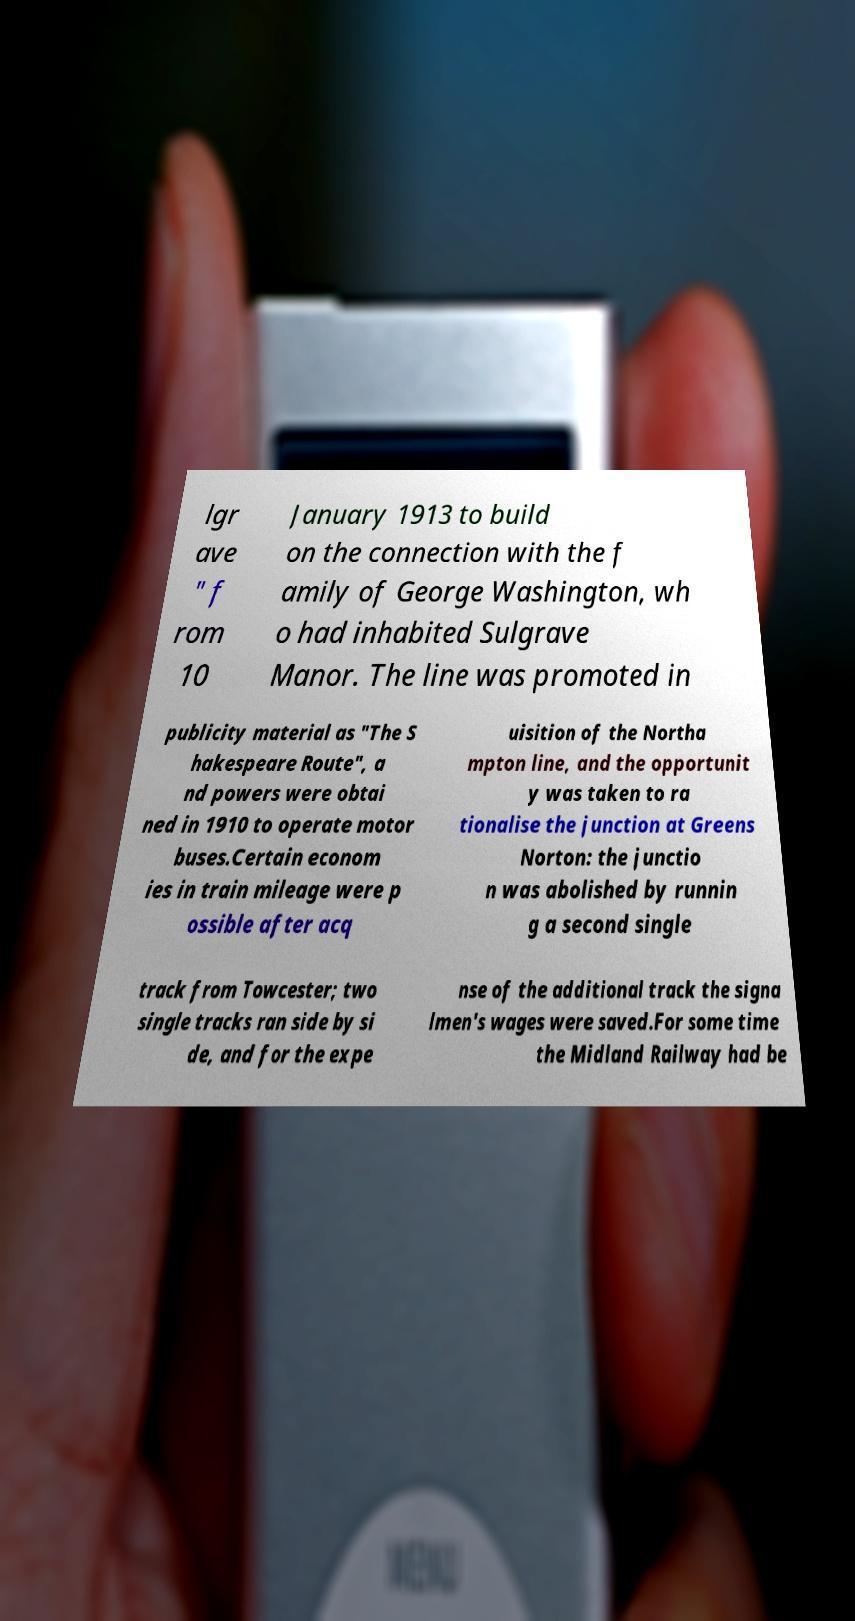Could you assist in decoding the text presented in this image and type it out clearly? lgr ave " f rom 10 January 1913 to build on the connection with the f amily of George Washington, wh o had inhabited Sulgrave Manor. The line was promoted in publicity material as "The S hakespeare Route", a nd powers were obtai ned in 1910 to operate motor buses.Certain econom ies in train mileage were p ossible after acq uisition of the Northa mpton line, and the opportunit y was taken to ra tionalise the junction at Greens Norton: the junctio n was abolished by runnin g a second single track from Towcester; two single tracks ran side by si de, and for the expe nse of the additional track the signa lmen's wages were saved.For some time the Midland Railway had be 